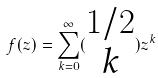<formula> <loc_0><loc_0><loc_500><loc_500>f ( z ) = \sum _ { k = 0 } ^ { \infty } ( \begin{matrix} 1 / 2 \\ k \end{matrix} ) z ^ { k }</formula> 